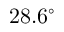Convert formula to latex. <formula><loc_0><loc_0><loc_500><loc_500>2 8 . 6 ^ { \circ }</formula> 